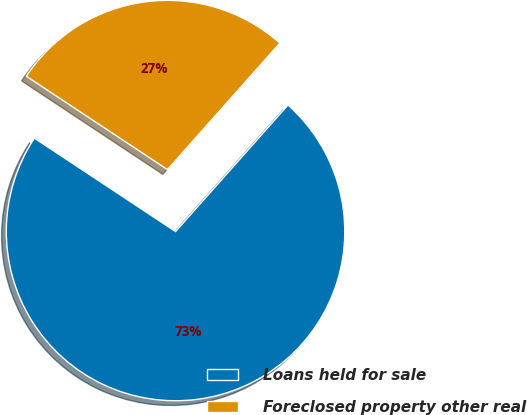Convert chart. <chart><loc_0><loc_0><loc_500><loc_500><pie_chart><fcel>Loans held for sale<fcel>Foreclosed property other real<nl><fcel>72.74%<fcel>27.26%<nl></chart> 